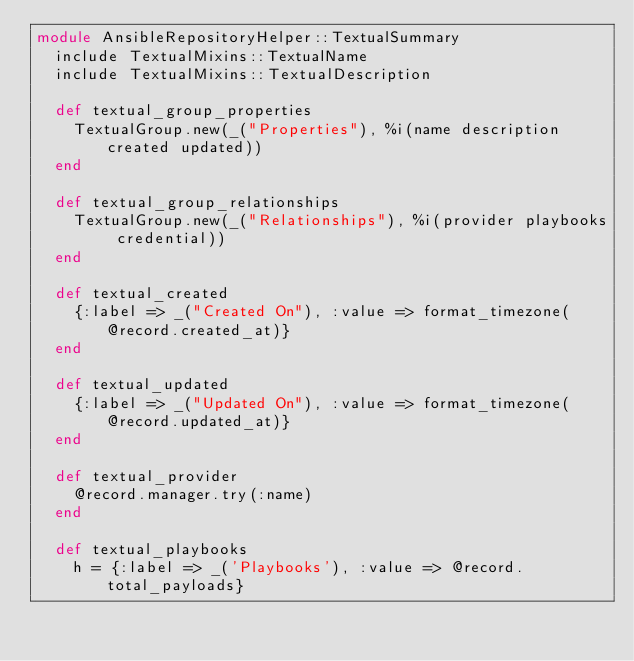Convert code to text. <code><loc_0><loc_0><loc_500><loc_500><_Ruby_>module AnsibleRepositoryHelper::TextualSummary
  include TextualMixins::TextualName
  include TextualMixins::TextualDescription

  def textual_group_properties
    TextualGroup.new(_("Properties"), %i(name description created updated))
  end

  def textual_group_relationships
    TextualGroup.new(_("Relationships"), %i(provider playbooks credential))
  end

  def textual_created
    {:label => _("Created On"), :value => format_timezone(@record.created_at)}
  end

  def textual_updated
    {:label => _("Updated On"), :value => format_timezone(@record.updated_at)}
  end

  def textual_provider
    @record.manager.try(:name)
  end

  def textual_playbooks
    h = {:label => _('Playbooks'), :value => @record.total_payloads}</code> 